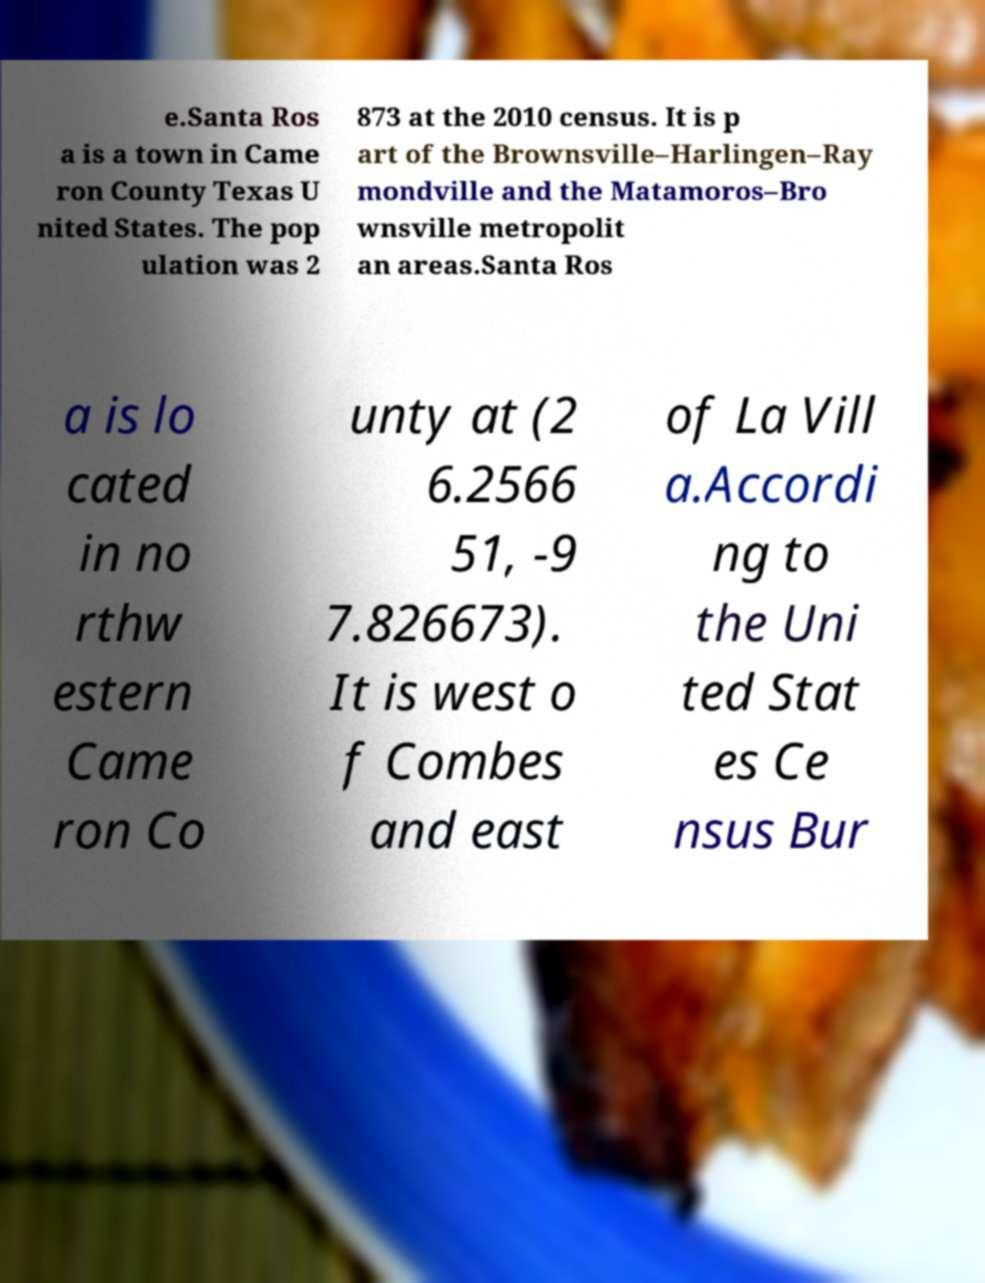For documentation purposes, I need the text within this image transcribed. Could you provide that? e.Santa Ros a is a town in Came ron County Texas U nited States. The pop ulation was 2 873 at the 2010 census. It is p art of the Brownsville–Harlingen–Ray mondville and the Matamoros–Bro wnsville metropolit an areas.Santa Ros a is lo cated in no rthw estern Came ron Co unty at (2 6.2566 51, -9 7.826673). It is west o f Combes and east of La Vill a.Accordi ng to the Uni ted Stat es Ce nsus Bur 